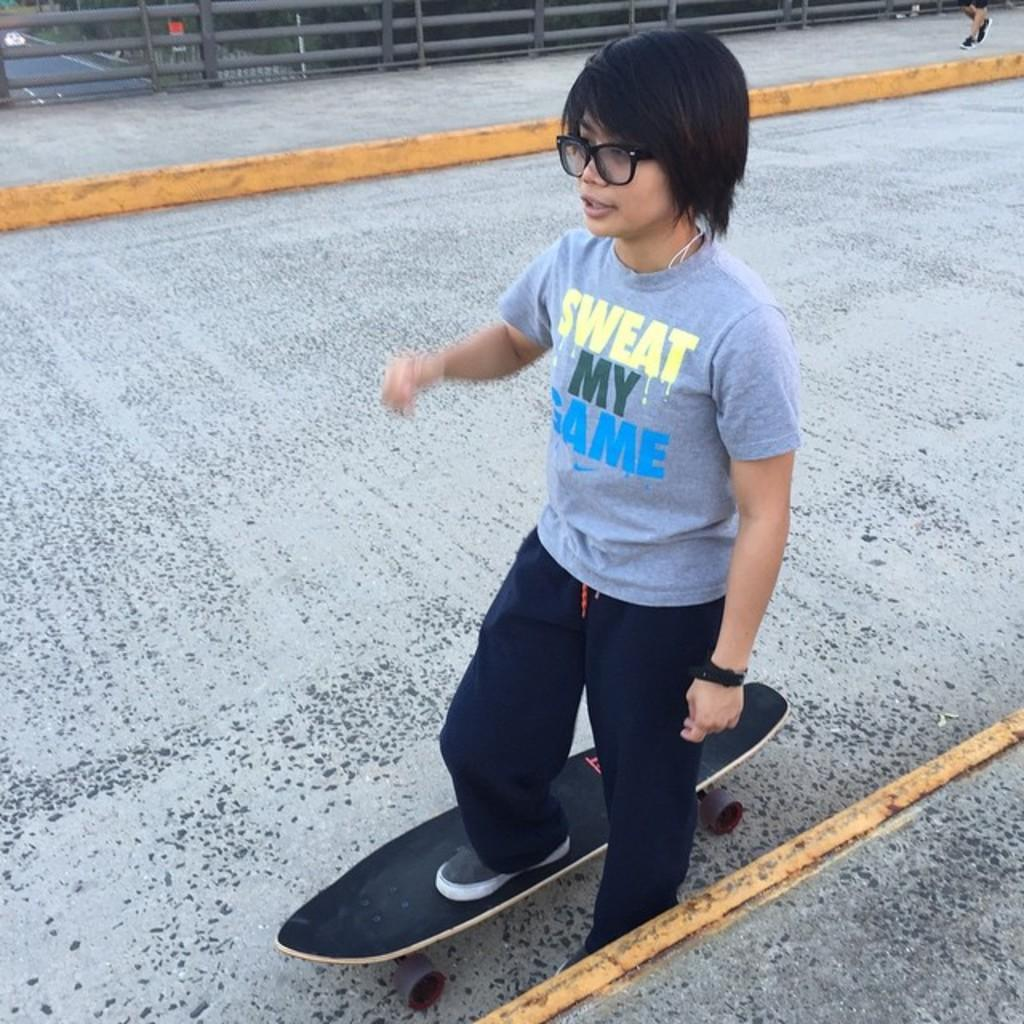What is the main subject of the image? There is a person in the image. What is the person doing in the image? The person is standing on a skateboard. What type of caption is written on the skateboard in the image? There is no caption written on the skateboard in the image. What type of soap is the person holding in the image? There is no soap present in the image. 